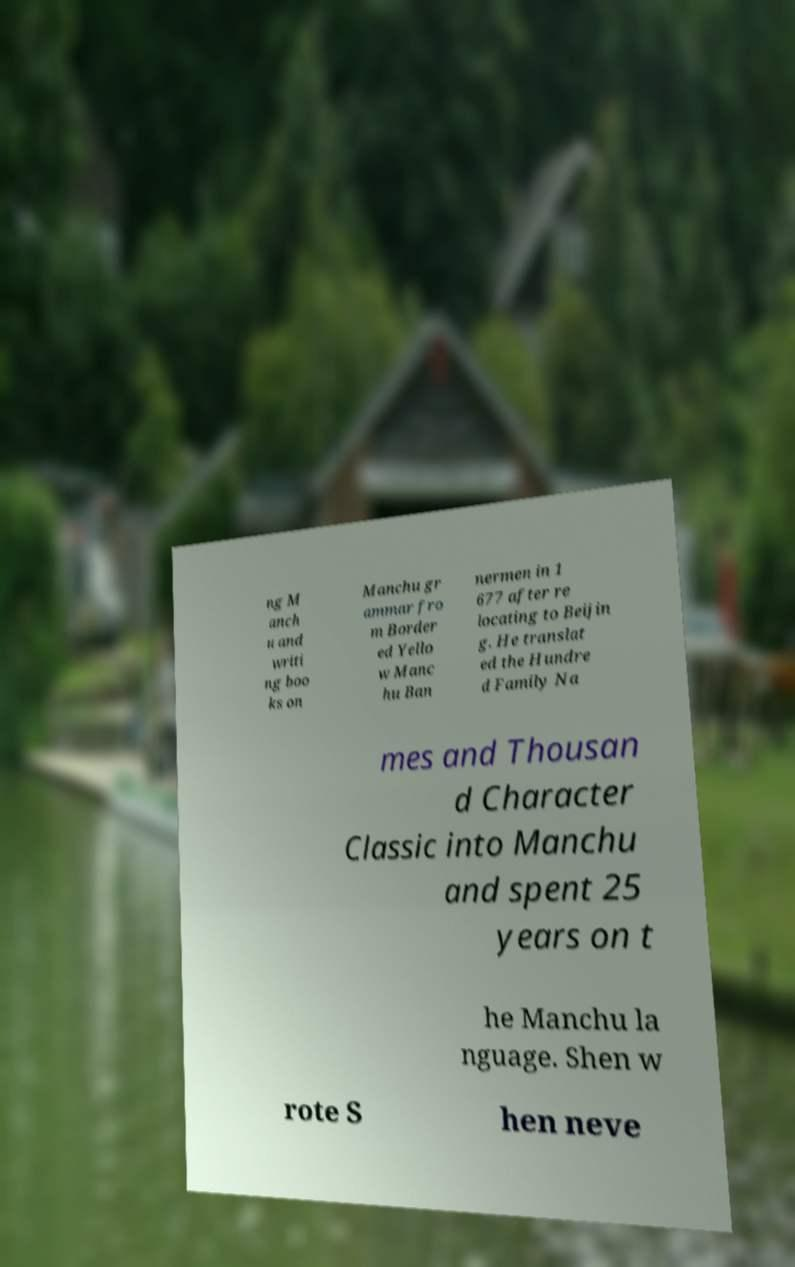Can you accurately transcribe the text from the provided image for me? ng M anch u and writi ng boo ks on Manchu gr ammar fro m Border ed Yello w Manc hu Ban nermen in 1 677 after re locating to Beijin g. He translat ed the Hundre d Family Na mes and Thousan d Character Classic into Manchu and spent 25 years on t he Manchu la nguage. Shen w rote S hen neve 